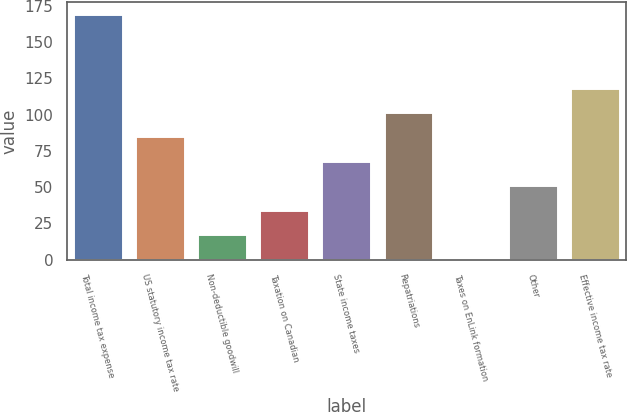Convert chart. <chart><loc_0><loc_0><loc_500><loc_500><bar_chart><fcel>Total income tax expense<fcel>US statutory income tax rate<fcel>Non-deductible goodwill<fcel>Taxation on Canadian<fcel>State income taxes<fcel>Repatriations<fcel>Taxes on EnLink formation<fcel>Other<fcel>Effective income tax rate<nl><fcel>169<fcel>84.88<fcel>17.56<fcel>34.39<fcel>68.05<fcel>101.71<fcel>0.73<fcel>51.22<fcel>118.54<nl></chart> 